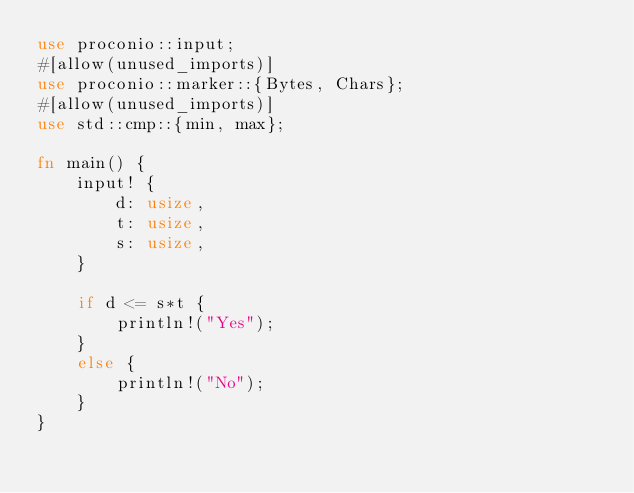Convert code to text. <code><loc_0><loc_0><loc_500><loc_500><_Rust_>use proconio::input;
#[allow(unused_imports)]
use proconio::marker::{Bytes, Chars};
#[allow(unused_imports)]
use std::cmp::{min, max};

fn main() {
	input! {
		d: usize,
		t: usize,
		s: usize,
	}

	if d <= s*t {
		println!("Yes");
	}
	else {
		println!("No");
	}
}

</code> 